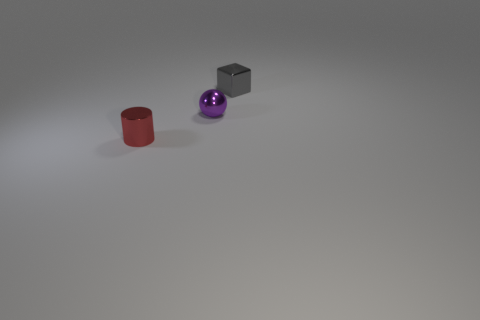Add 2 red objects. How many objects exist? 5 Subtract all cylinders. How many objects are left? 2 Add 3 tiny purple metal things. How many tiny purple metal things are left? 4 Add 2 small purple metal spheres. How many small purple metal spheres exist? 3 Subtract 1 purple spheres. How many objects are left? 2 Subtract all gray metallic blocks. Subtract all small purple metal spheres. How many objects are left? 1 